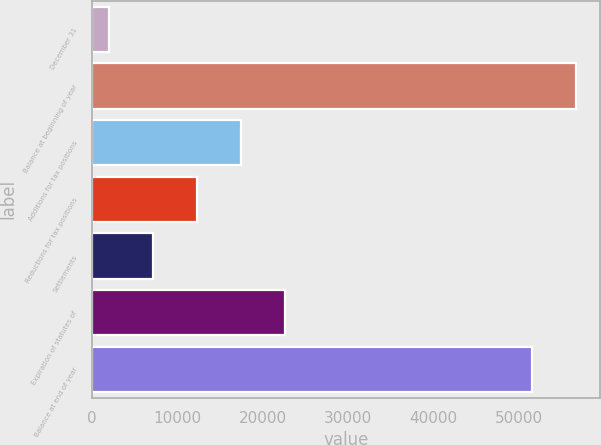Convert chart. <chart><loc_0><loc_0><loc_500><loc_500><bar_chart><fcel>December 31<fcel>Balance at beginning of year<fcel>Additions for tax positions<fcel>Reductions for tax positions<fcel>Settlements<fcel>Expiration of statutes of<fcel>Balance at end of year<nl><fcel>2012<fcel>56674.1<fcel>17474.3<fcel>12320.2<fcel>7166.1<fcel>22628.4<fcel>51520<nl></chart> 